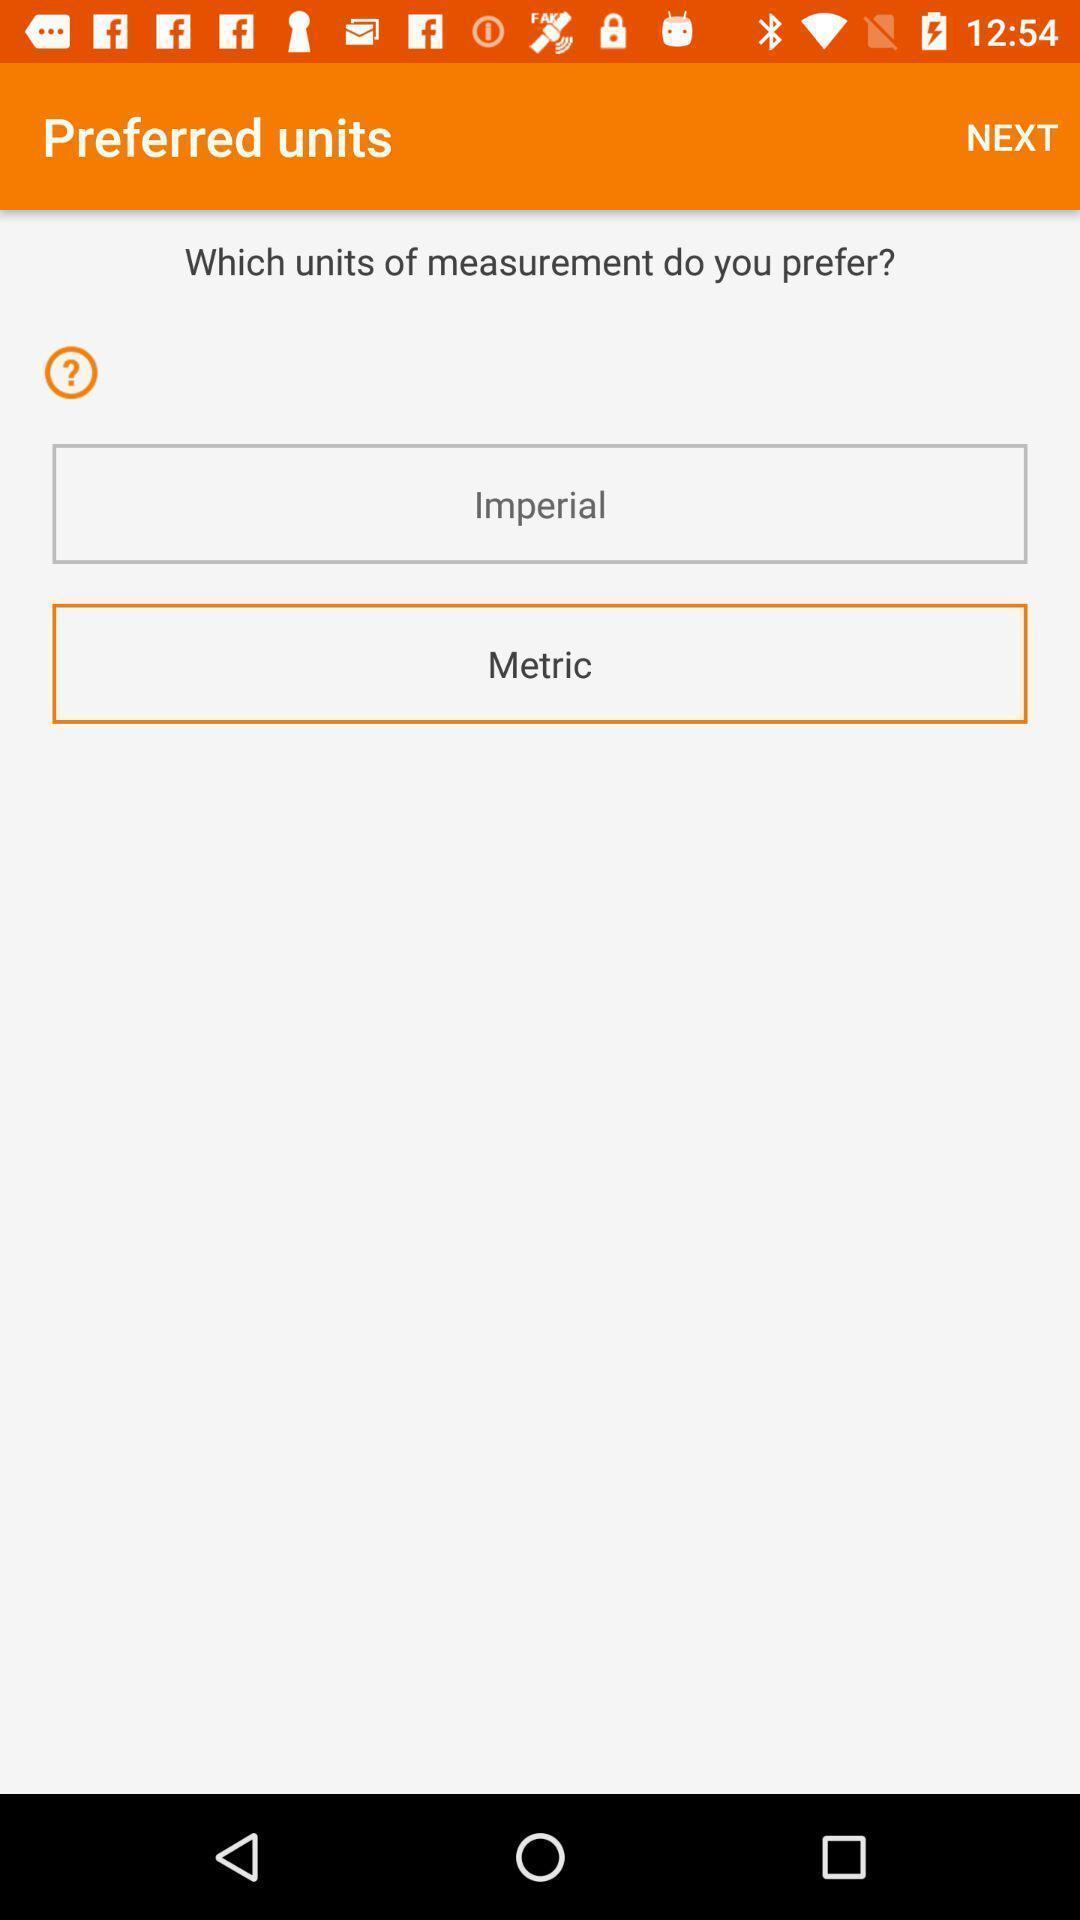Explain the elements present in this screenshot. Units page in a meal planning app. 